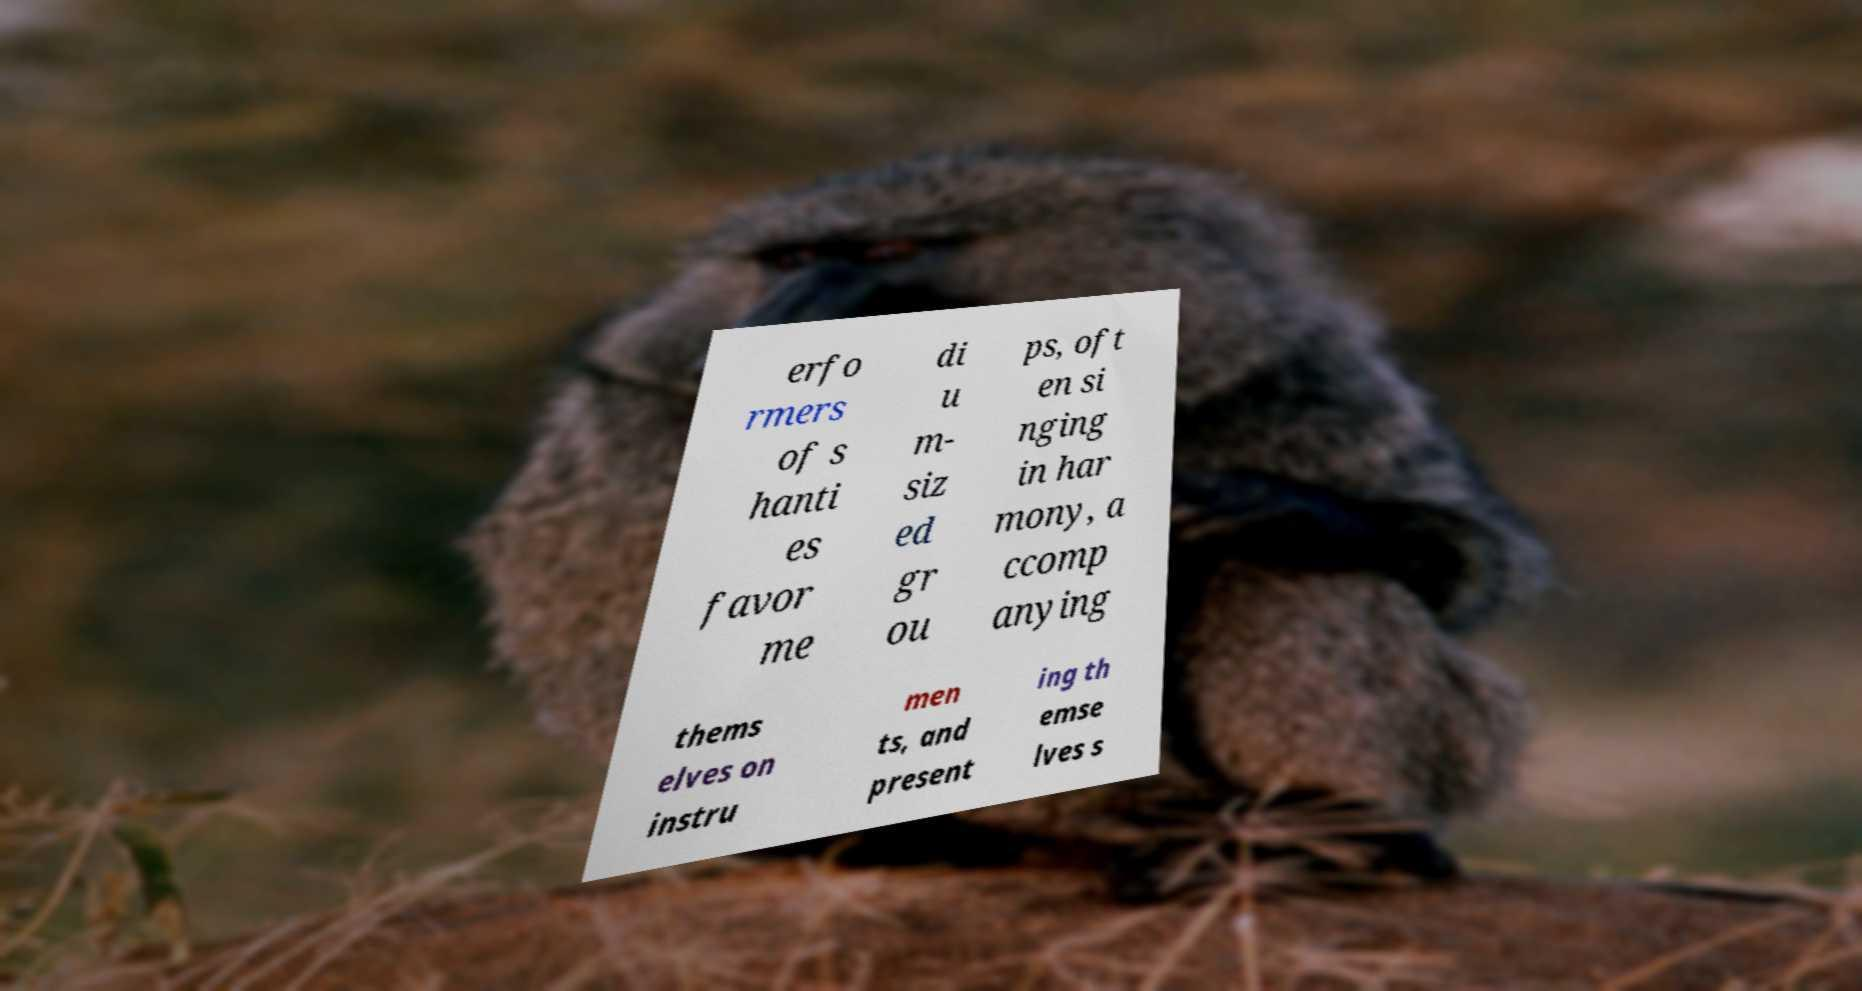For documentation purposes, I need the text within this image transcribed. Could you provide that? erfo rmers of s hanti es favor me di u m- siz ed gr ou ps, oft en si nging in har mony, a ccomp anying thems elves on instru men ts, and present ing th emse lves s 